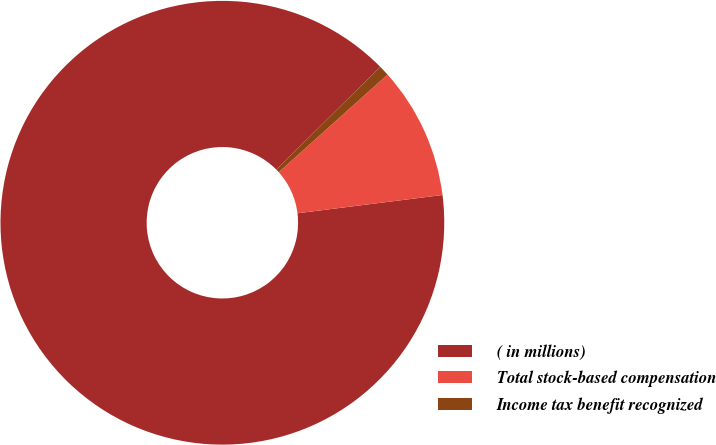<chart> <loc_0><loc_0><loc_500><loc_500><pie_chart><fcel>( in millions)<fcel>Total stock-based compensation<fcel>Income tax benefit recognized<nl><fcel>89.6%<fcel>9.64%<fcel>0.76%<nl></chart> 